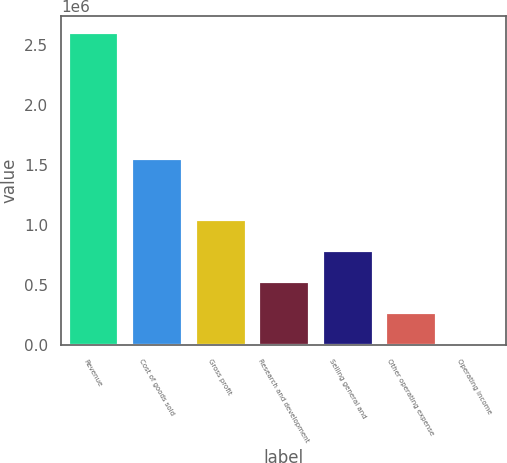<chart> <loc_0><loc_0><loc_500><loc_500><bar_chart><fcel>Revenue<fcel>Cost of goods sold<fcel>Gross profit<fcel>Research and development<fcel>Selling general and<fcel>Other operating expense<fcel>Operating income<nl><fcel>2.61073e+06<fcel>1.56117e+06<fcel>1.05147e+06<fcel>531720<fcel>791595<fcel>271844<fcel>11968<nl></chart> 